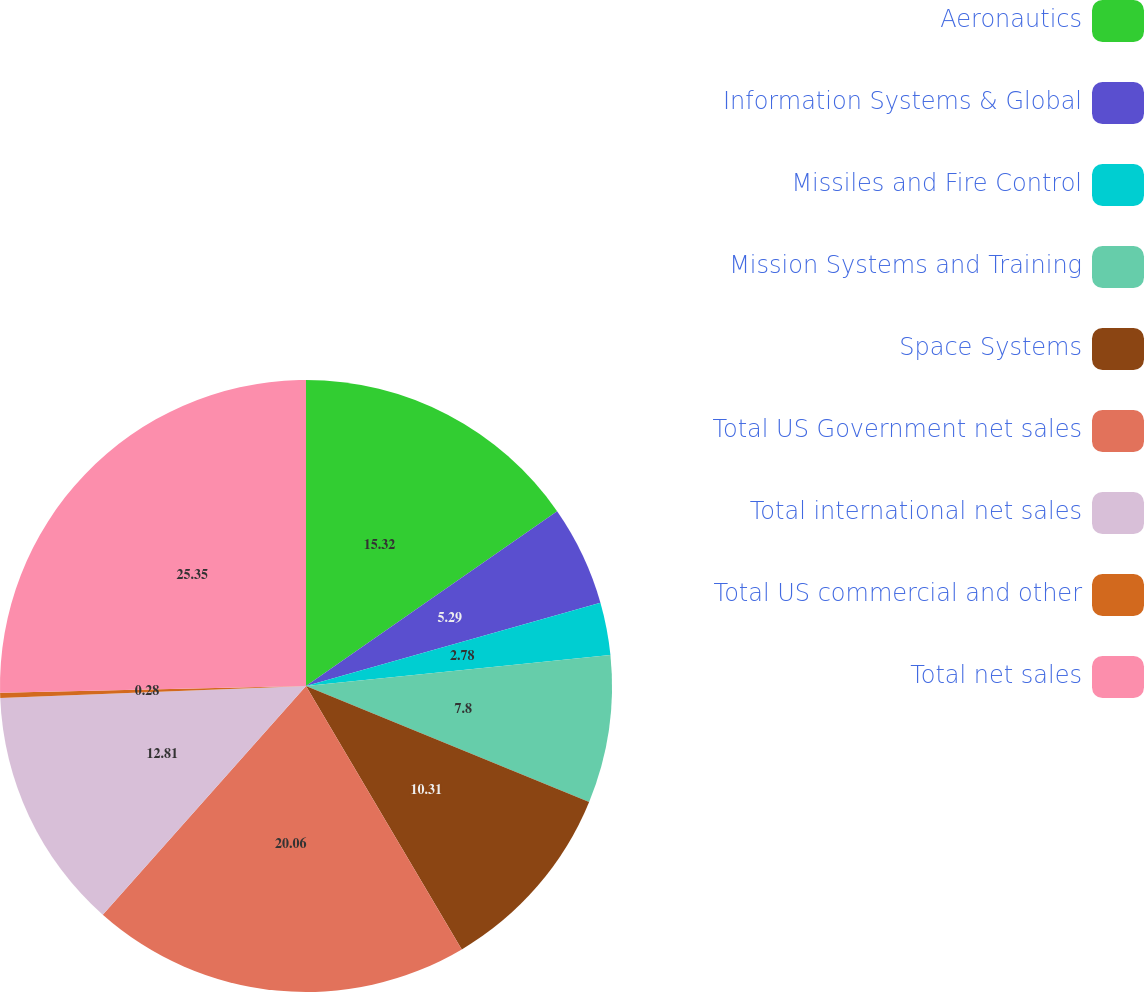Convert chart to OTSL. <chart><loc_0><loc_0><loc_500><loc_500><pie_chart><fcel>Aeronautics<fcel>Information Systems & Global<fcel>Missiles and Fire Control<fcel>Mission Systems and Training<fcel>Space Systems<fcel>Total US Government net sales<fcel>Total international net sales<fcel>Total US commercial and other<fcel>Total net sales<nl><fcel>15.32%<fcel>5.29%<fcel>2.78%<fcel>7.8%<fcel>10.31%<fcel>20.06%<fcel>12.81%<fcel>0.28%<fcel>25.35%<nl></chart> 